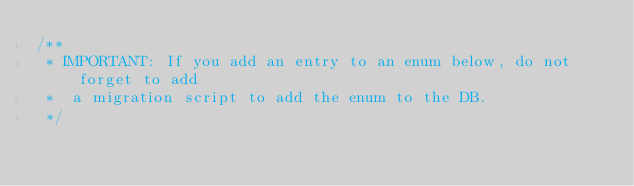Convert code to text. <code><loc_0><loc_0><loc_500><loc_500><_JavaScript_>/**
 * IMPORTANT: If you add an entry to an enum below, do not forget to add
 *  a migration script to add the enum to the DB.
 */
</code> 